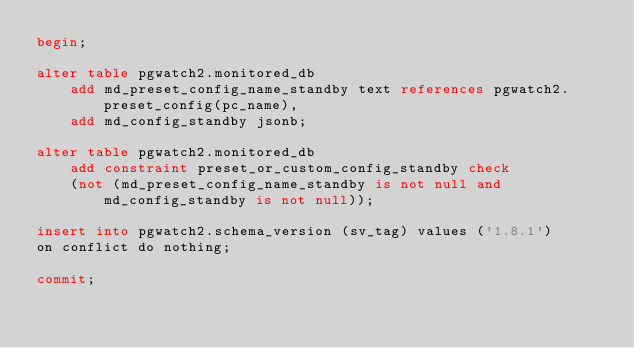<code> <loc_0><loc_0><loc_500><loc_500><_SQL_>begin;

alter table pgwatch2.monitored_db
    add md_preset_config_name_standby text references pgwatch2.preset_config(pc_name),
    add md_config_standby jsonb;

alter table pgwatch2.monitored_db
    add constraint preset_or_custom_config_standby check
    (not (md_preset_config_name_standby is not null and md_config_standby is not null));

insert into pgwatch2.schema_version (sv_tag) values ('1.8.1')
on conflict do nothing;

commit;
</code> 